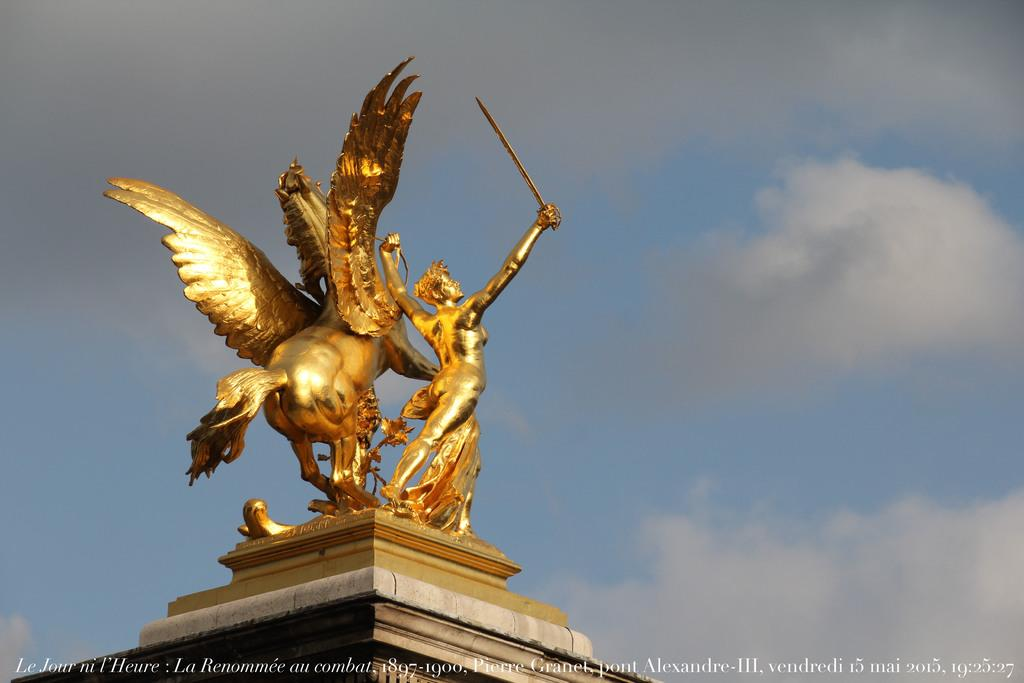What is the main subject of the image? There is a statue in the image. Where is the statue located? The statue is on a platform. What can be seen in the background of the image? There is sky visible in the background of the image. Is there any text present in the image? Yes, there is text at the bottom of the image. What type of underwear is the statue wearing in the image? There is no underwear visible in the image, as the statue is not a person and does not wear clothing. 